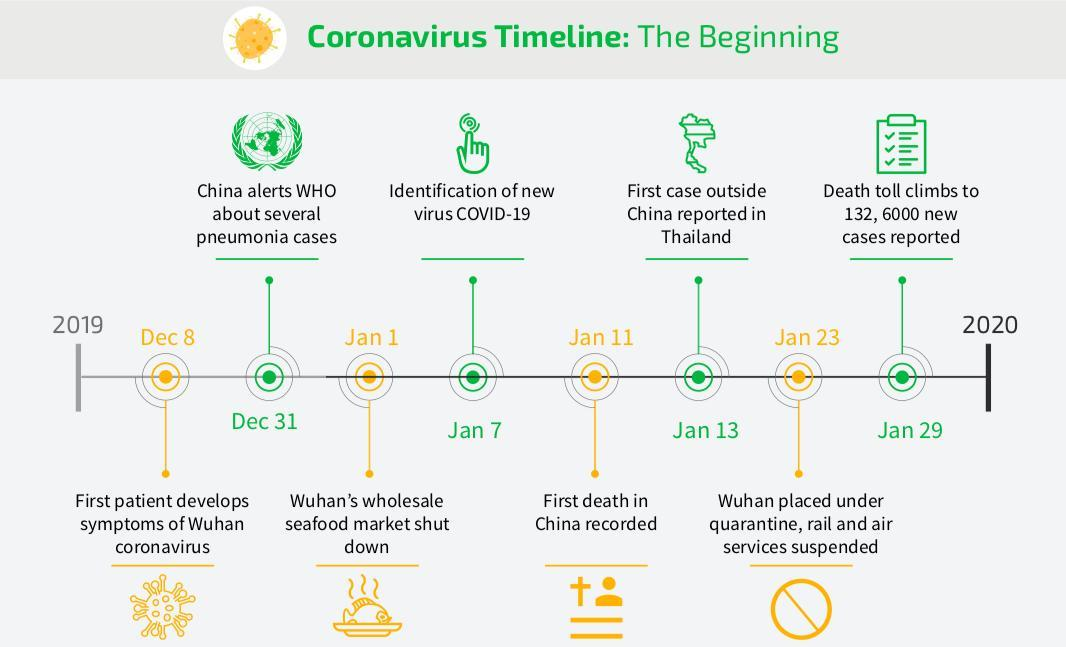When was the new virus called COVID-19 identified?
Answer the question with a short phrase. Jan 7 When was the first case of COVID-19 reported outside China? Jan 13 2020 When was the first COVID-19 death reported in China? Jan 11 